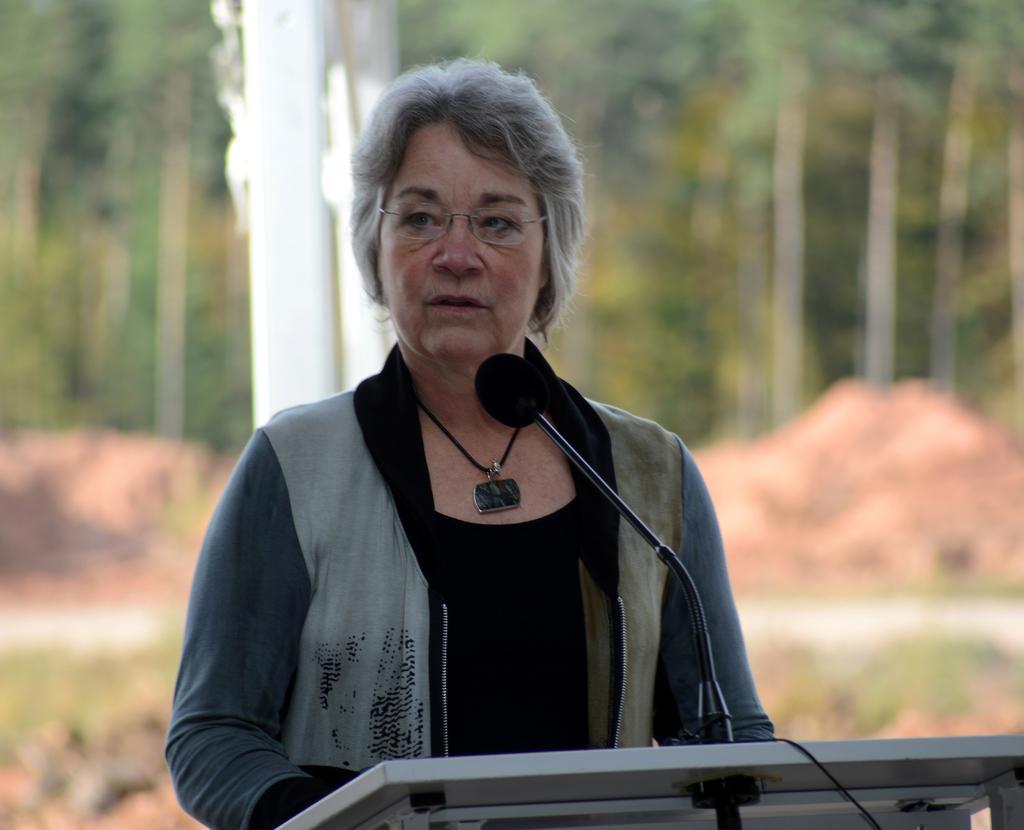Can you describe this image briefly? In the center of the image, we can see a lady standing and wearing glasses and in the front, we can see a podium and a mic. In the background, there are trees and we can see rocks. 